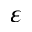<formula> <loc_0><loc_0><loc_500><loc_500>\varepsilon</formula> 